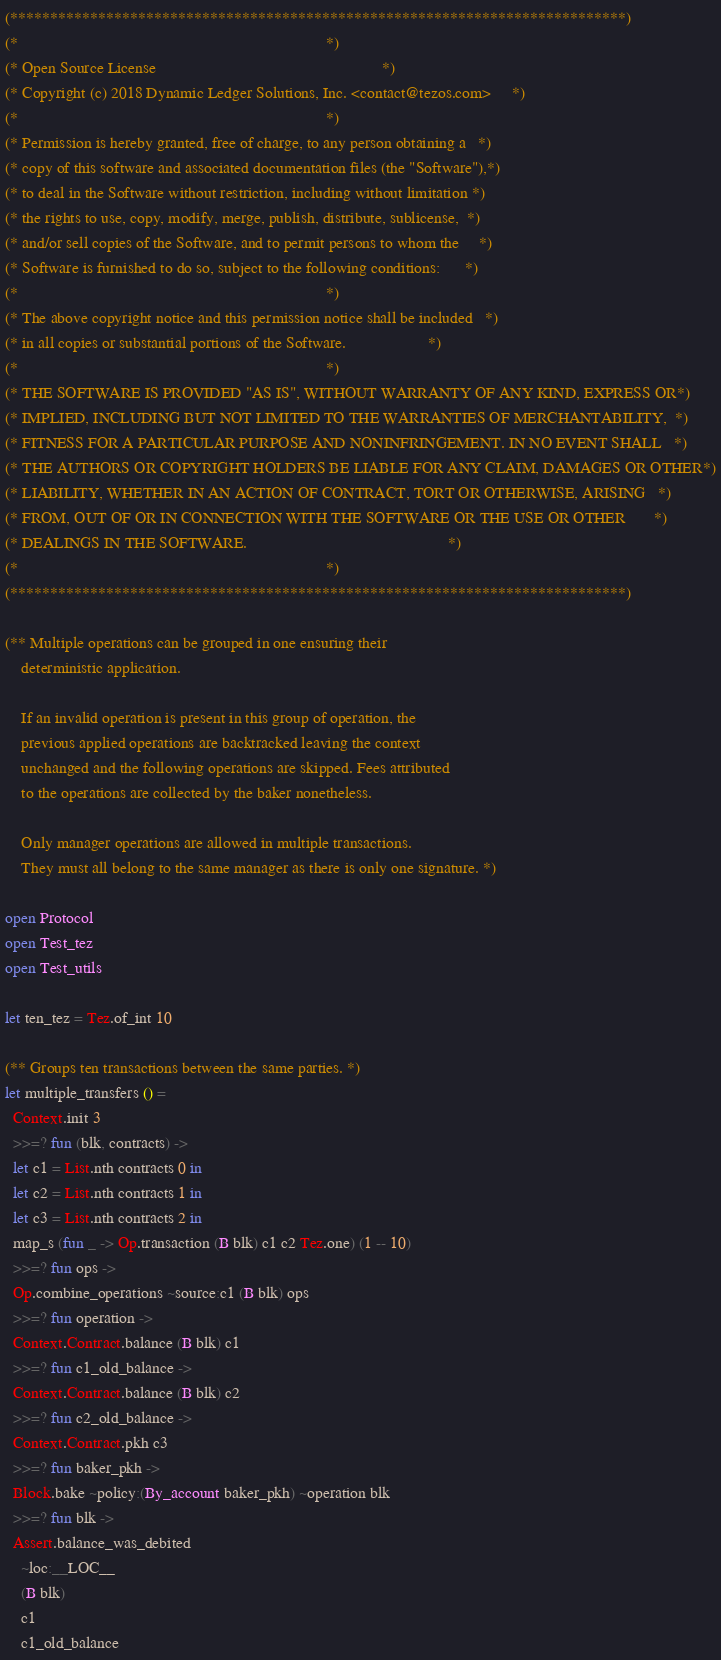Convert code to text. <code><loc_0><loc_0><loc_500><loc_500><_OCaml_>(*****************************************************************************)
(*                                                                           *)
(* Open Source License                                                       *)
(* Copyright (c) 2018 Dynamic Ledger Solutions, Inc. <contact@tezos.com>     *)
(*                                                                           *)
(* Permission is hereby granted, free of charge, to any person obtaining a   *)
(* copy of this software and associated documentation files (the "Software"),*)
(* to deal in the Software without restriction, including without limitation *)
(* the rights to use, copy, modify, merge, publish, distribute, sublicense,  *)
(* and/or sell copies of the Software, and to permit persons to whom the     *)
(* Software is furnished to do so, subject to the following conditions:      *)
(*                                                                           *)
(* The above copyright notice and this permission notice shall be included   *)
(* in all copies or substantial portions of the Software.                    *)
(*                                                                           *)
(* THE SOFTWARE IS PROVIDED "AS IS", WITHOUT WARRANTY OF ANY KIND, EXPRESS OR*)
(* IMPLIED, INCLUDING BUT NOT LIMITED TO THE WARRANTIES OF MERCHANTABILITY,  *)
(* FITNESS FOR A PARTICULAR PURPOSE AND NONINFRINGEMENT. IN NO EVENT SHALL   *)
(* THE AUTHORS OR COPYRIGHT HOLDERS BE LIABLE FOR ANY CLAIM, DAMAGES OR OTHER*)
(* LIABILITY, WHETHER IN AN ACTION OF CONTRACT, TORT OR OTHERWISE, ARISING   *)
(* FROM, OUT OF OR IN CONNECTION WITH THE SOFTWARE OR THE USE OR OTHER       *)
(* DEALINGS IN THE SOFTWARE.                                                 *)
(*                                                                           *)
(*****************************************************************************)

(** Multiple operations can be grouped in one ensuring their
    deterministic application.

    If an invalid operation is present in this group of operation, the
    previous applied operations are backtracked leaving the context
    unchanged and the following operations are skipped. Fees attributed
    to the operations are collected by the baker nonetheless.

    Only manager operations are allowed in multiple transactions.
    They must all belong to the same manager as there is only one signature. *)

open Protocol
open Test_tez
open Test_utils

let ten_tez = Tez.of_int 10

(** Groups ten transactions between the same parties. *)
let multiple_transfers () =
  Context.init 3
  >>=? fun (blk, contracts) ->
  let c1 = List.nth contracts 0 in
  let c2 = List.nth contracts 1 in
  let c3 = List.nth contracts 2 in
  map_s (fun _ -> Op.transaction (B blk) c1 c2 Tez.one) (1 -- 10)
  >>=? fun ops ->
  Op.combine_operations ~source:c1 (B blk) ops
  >>=? fun operation ->
  Context.Contract.balance (B blk) c1
  >>=? fun c1_old_balance ->
  Context.Contract.balance (B blk) c2
  >>=? fun c2_old_balance ->
  Context.Contract.pkh c3
  >>=? fun baker_pkh ->
  Block.bake ~policy:(By_account baker_pkh) ~operation blk
  >>=? fun blk ->
  Assert.balance_was_debited
    ~loc:__LOC__
    (B blk)
    c1
    c1_old_balance</code> 